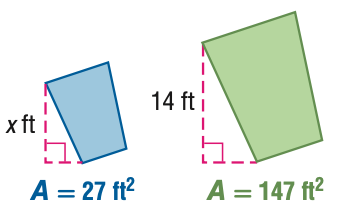Answer the mathemtical geometry problem and directly provide the correct option letter.
Question: For the pair of similar figures, use the given areas to find the scale factor of the blue to the green figure.
Choices: A: \frac { 9 } { 49 } B: \frac { 3 } { 7 } C: \frac { 7 } { 3 } D: \frac { 49 } { 9 } B 